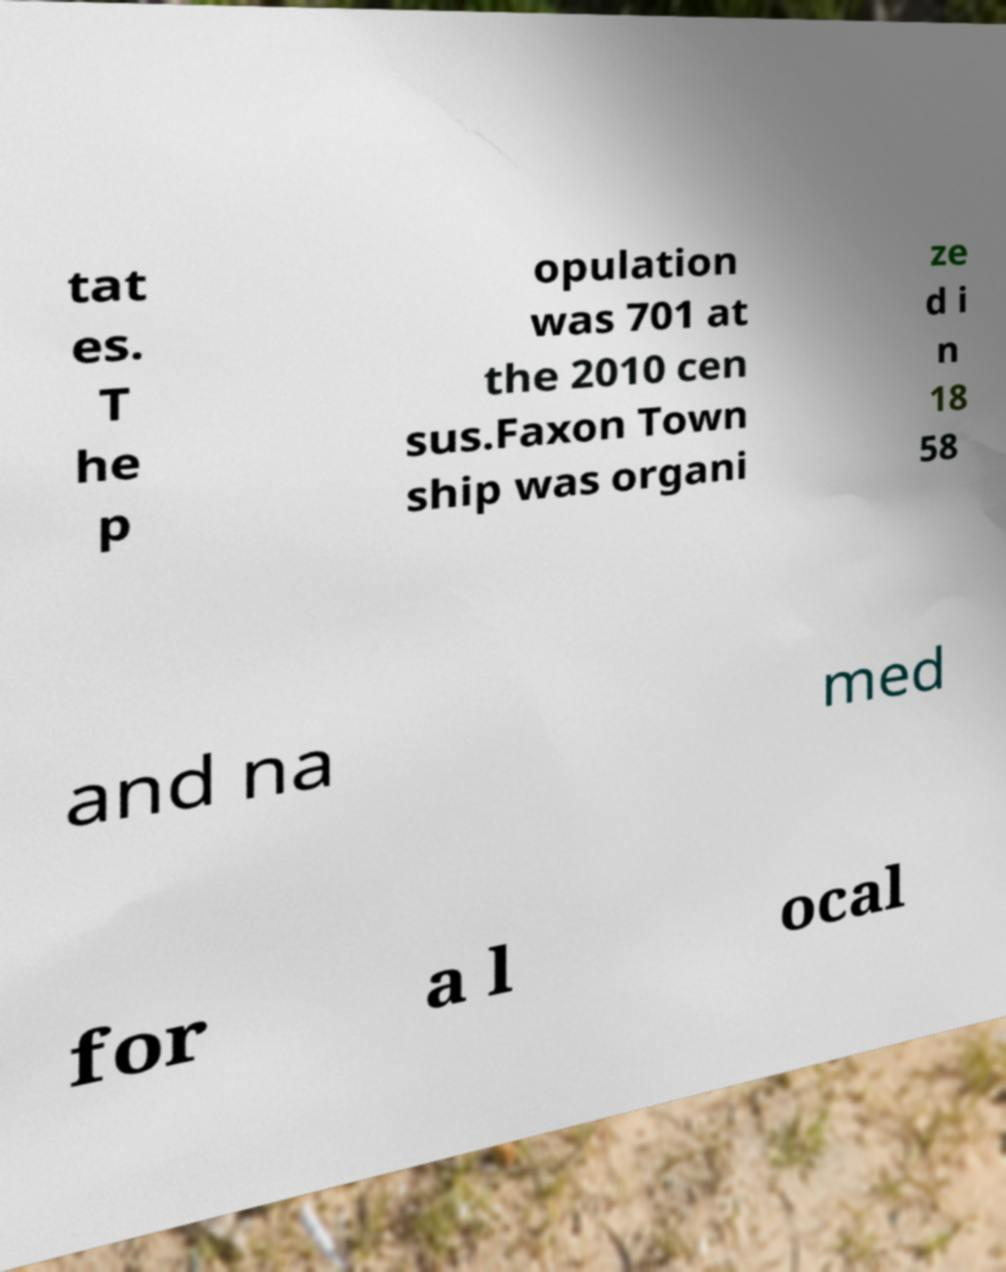Could you extract and type out the text from this image? tat es. T he p opulation was 701 at the 2010 cen sus.Faxon Town ship was organi ze d i n 18 58 and na med for a l ocal 